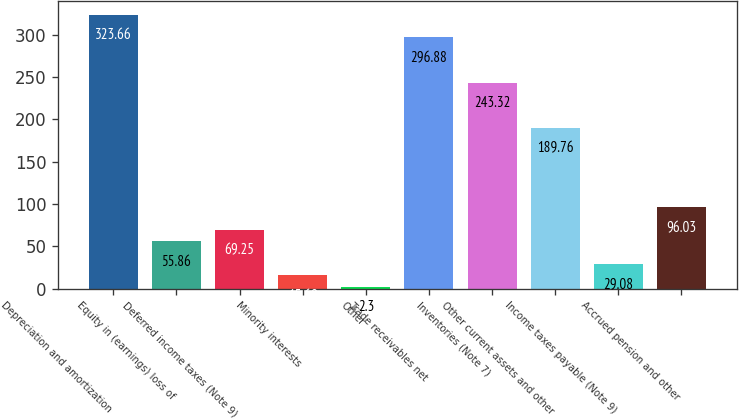Convert chart. <chart><loc_0><loc_0><loc_500><loc_500><bar_chart><fcel>Depreciation and amortization<fcel>Equity in (earnings) loss of<fcel>Deferred income taxes (Note 9)<fcel>Minority interests<fcel>Other<fcel>Trade receivables net<fcel>Inventories (Note 7)<fcel>Other current assets and other<fcel>Income taxes payable (Note 9)<fcel>Accrued pension and other<nl><fcel>323.66<fcel>55.86<fcel>69.25<fcel>15.69<fcel>2.3<fcel>296.88<fcel>243.32<fcel>189.76<fcel>29.08<fcel>96.03<nl></chart> 